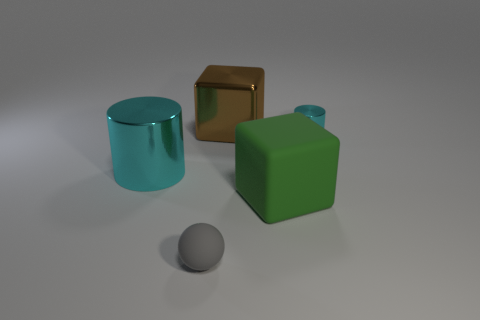The cylinder to the left of the cylinder that is behind the big cyan object is made of what material?
Ensure brevity in your answer.  Metal. Are there an equal number of large green things that are in front of the big green rubber thing and big brown metal blocks that are in front of the big brown thing?
Keep it short and to the point. Yes. Do the large green object and the tiny cyan shiny object have the same shape?
Ensure brevity in your answer.  No. There is a big object that is both left of the green rubber block and in front of the shiny cube; what is its material?
Make the answer very short. Metal. How many big brown metallic things have the same shape as the green thing?
Give a very brief answer. 1. How big is the green rubber cube right of the matte sphere to the right of the cyan metallic cylinder that is on the left side of the large green thing?
Ensure brevity in your answer.  Large. Is the number of matte cubes on the right side of the brown thing greater than the number of small cyan metal blocks?
Your answer should be compact. Yes. Are there any tiny cyan cylinders?
Make the answer very short. Yes. What number of cyan shiny cylinders are the same size as the green rubber block?
Ensure brevity in your answer.  1. Is the number of tiny matte balls that are in front of the tiny shiny cylinder greater than the number of small matte things on the right side of the small gray rubber ball?
Your response must be concise. Yes. 